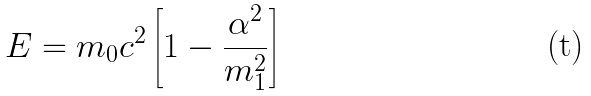<formula> <loc_0><loc_0><loc_500><loc_500>E = m _ { 0 } c ^ { 2 } \left [ 1 - \frac { \alpha ^ { 2 } } { m ^ { 2 } _ { 1 } } \right ]</formula> 